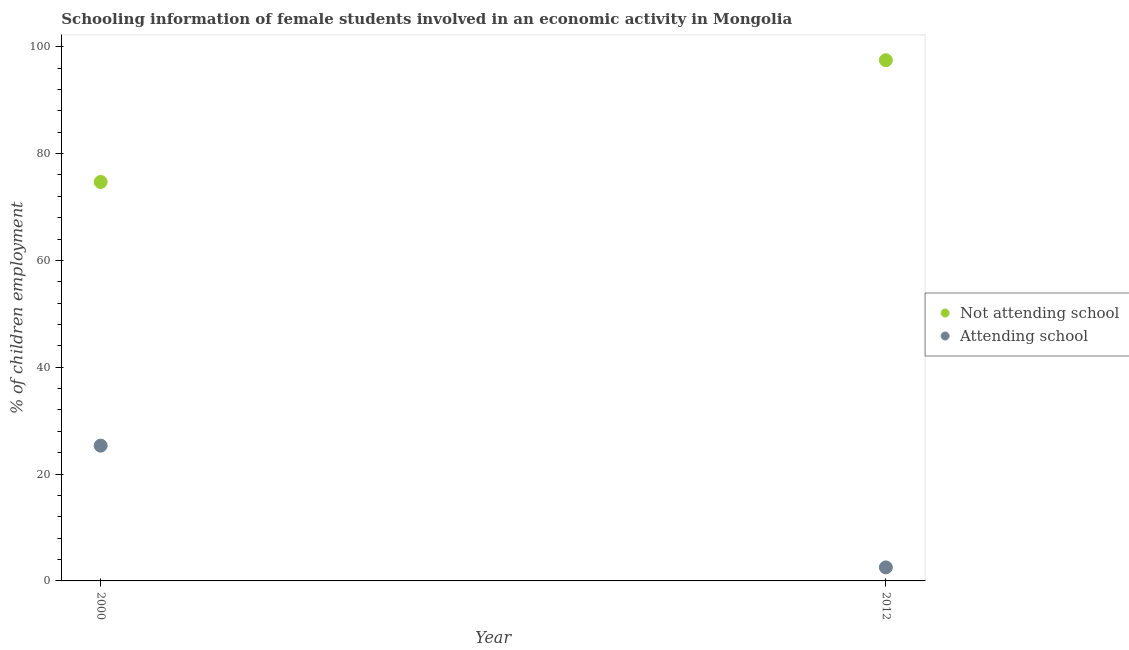How many different coloured dotlines are there?
Give a very brief answer. 2. Is the number of dotlines equal to the number of legend labels?
Offer a terse response. Yes. What is the percentage of employed females who are attending school in 2000?
Provide a short and direct response. 25.32. Across all years, what is the maximum percentage of employed females who are not attending school?
Make the answer very short. 97.47. Across all years, what is the minimum percentage of employed females who are attending school?
Your response must be concise. 2.53. In which year was the percentage of employed females who are not attending school maximum?
Give a very brief answer. 2012. What is the total percentage of employed females who are attending school in the graph?
Provide a short and direct response. 27.85. What is the difference between the percentage of employed females who are attending school in 2000 and that in 2012?
Make the answer very short. 22.79. What is the difference between the percentage of employed females who are not attending school in 2012 and the percentage of employed females who are attending school in 2000?
Give a very brief answer. 72.15. What is the average percentage of employed females who are not attending school per year?
Your response must be concise. 86.07. In the year 2000, what is the difference between the percentage of employed females who are attending school and percentage of employed females who are not attending school?
Provide a succinct answer. -49.36. In how many years, is the percentage of employed females who are attending school greater than 72 %?
Offer a very short reply. 0. What is the ratio of the percentage of employed females who are not attending school in 2000 to that in 2012?
Ensure brevity in your answer.  0.77. How many dotlines are there?
Provide a short and direct response. 2. What is the difference between two consecutive major ticks on the Y-axis?
Offer a terse response. 20. Does the graph contain any zero values?
Make the answer very short. No. Does the graph contain grids?
Ensure brevity in your answer.  No. Where does the legend appear in the graph?
Make the answer very short. Center right. How are the legend labels stacked?
Your response must be concise. Vertical. What is the title of the graph?
Give a very brief answer. Schooling information of female students involved in an economic activity in Mongolia. What is the label or title of the X-axis?
Provide a short and direct response. Year. What is the label or title of the Y-axis?
Ensure brevity in your answer.  % of children employment. What is the % of children employment of Not attending school in 2000?
Give a very brief answer. 74.68. What is the % of children employment in Attending school in 2000?
Your answer should be very brief. 25.32. What is the % of children employment in Not attending school in 2012?
Make the answer very short. 97.47. What is the % of children employment of Attending school in 2012?
Your answer should be compact. 2.53. Across all years, what is the maximum % of children employment in Not attending school?
Offer a terse response. 97.47. Across all years, what is the maximum % of children employment in Attending school?
Provide a succinct answer. 25.32. Across all years, what is the minimum % of children employment in Not attending school?
Make the answer very short. 74.68. Across all years, what is the minimum % of children employment in Attending school?
Provide a succinct answer. 2.53. What is the total % of children employment of Not attending school in the graph?
Offer a very short reply. 172.15. What is the total % of children employment of Attending school in the graph?
Your answer should be compact. 27.85. What is the difference between the % of children employment in Not attending school in 2000 and that in 2012?
Offer a terse response. -22.79. What is the difference between the % of children employment in Attending school in 2000 and that in 2012?
Make the answer very short. 22.79. What is the difference between the % of children employment of Not attending school in 2000 and the % of children employment of Attending school in 2012?
Your answer should be compact. 72.15. What is the average % of children employment of Not attending school per year?
Ensure brevity in your answer.  86.08. What is the average % of children employment in Attending school per year?
Your response must be concise. 13.93. In the year 2000, what is the difference between the % of children employment of Not attending school and % of children employment of Attending school?
Offer a terse response. 49.36. In the year 2012, what is the difference between the % of children employment of Not attending school and % of children employment of Attending school?
Offer a very short reply. 94.94. What is the ratio of the % of children employment of Not attending school in 2000 to that in 2012?
Ensure brevity in your answer.  0.77. What is the ratio of the % of children employment of Attending school in 2000 to that in 2012?
Offer a terse response. 10. What is the difference between the highest and the second highest % of children employment of Not attending school?
Provide a succinct answer. 22.79. What is the difference between the highest and the second highest % of children employment of Attending school?
Give a very brief answer. 22.79. What is the difference between the highest and the lowest % of children employment of Not attending school?
Keep it short and to the point. 22.79. What is the difference between the highest and the lowest % of children employment in Attending school?
Keep it short and to the point. 22.79. 